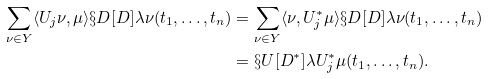<formula> <loc_0><loc_0><loc_500><loc_500>\sum _ { \nu \in Y } \langle U _ { j } \nu , \mu \rangle \S D [ D ] { \lambda } { \nu } ( t _ { 1 } , \dots , t _ { n } ) & = \sum _ { \nu \in Y } \langle \nu , U _ { j } ^ { \ast } \mu \rangle \S D [ D ] { \lambda } { \nu } ( t _ { 1 } , \dots , t _ { n } ) \\ & = \S U [ D ^ { \ast } ] { \lambda } { U ^ { \ast } _ { j } \mu } ( t _ { 1 } , \dots , t _ { n } ) .</formula> 